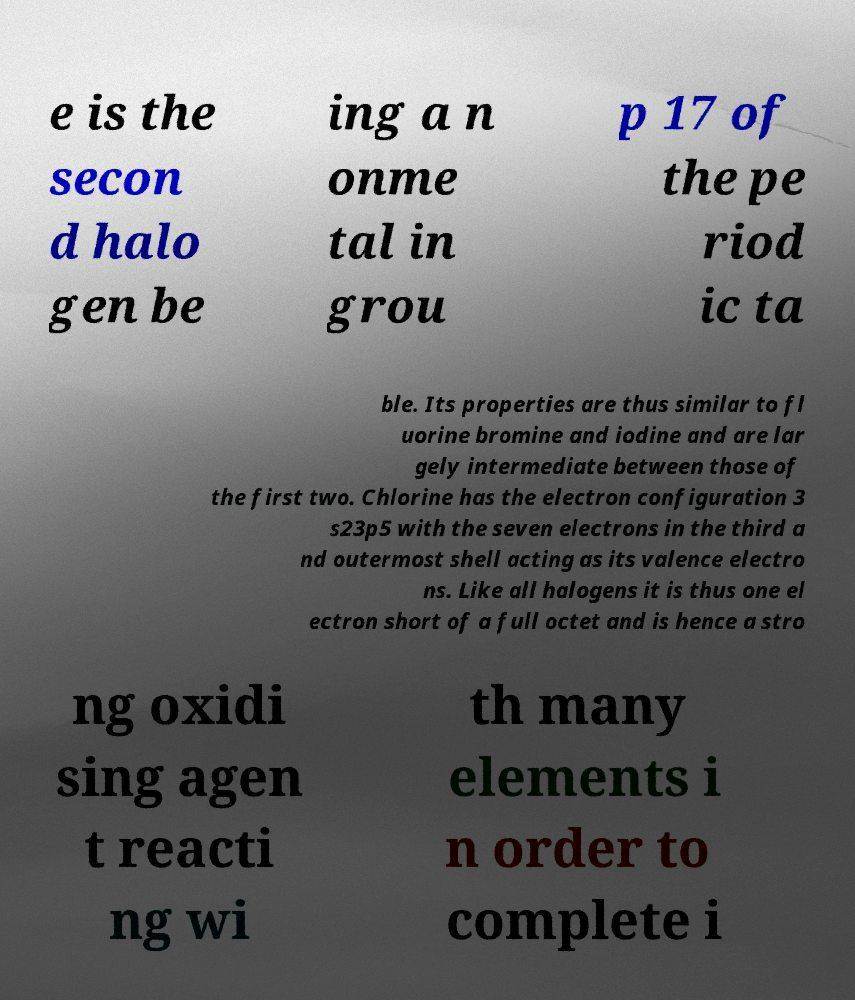Please read and relay the text visible in this image. What does it say? e is the secon d halo gen be ing a n onme tal in grou p 17 of the pe riod ic ta ble. Its properties are thus similar to fl uorine bromine and iodine and are lar gely intermediate between those of the first two. Chlorine has the electron configuration 3 s23p5 with the seven electrons in the third a nd outermost shell acting as its valence electro ns. Like all halogens it is thus one el ectron short of a full octet and is hence a stro ng oxidi sing agen t reacti ng wi th many elements i n order to complete i 